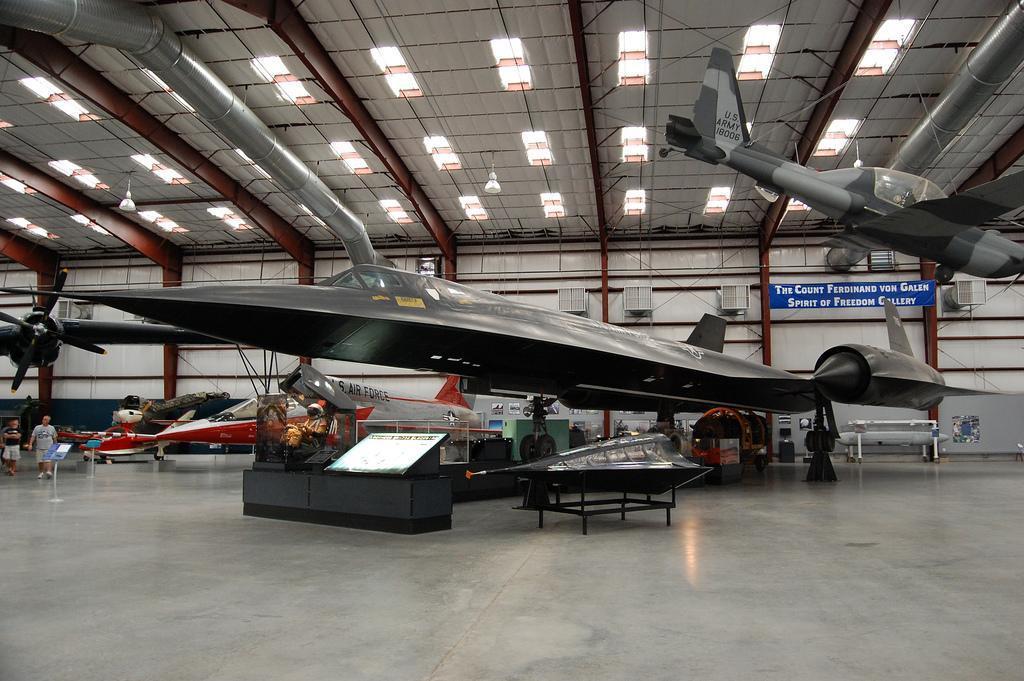How many big grey planes are on the ground?
Give a very brief answer. 1. 